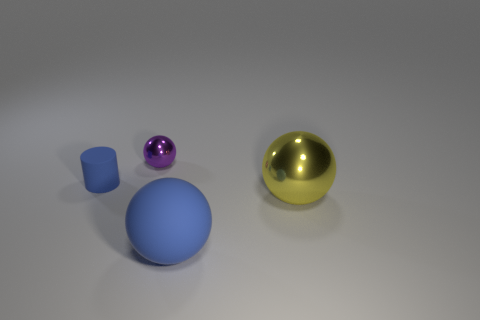What is the material of the purple sphere?
Your answer should be compact. Metal. There is a large metal thing; is it the same color as the rubber object that is on the left side of the blue ball?
Make the answer very short. No. What size is the object that is both to the right of the cylinder and left of the large blue thing?
Provide a succinct answer. Small. There is a big yellow object that is the same material as the purple thing; what shape is it?
Keep it short and to the point. Sphere. Are the small blue thing and the blue object on the right side of the purple shiny sphere made of the same material?
Your answer should be compact. Yes. There is a big thing that is left of the large yellow metallic object; are there any spheres that are in front of it?
Your response must be concise. No. What is the material of the yellow object that is the same shape as the tiny purple metal object?
Give a very brief answer. Metal. There is a rubber object in front of the large yellow shiny object; what number of small purple balls are to the right of it?
Give a very brief answer. 0. Are there any other things of the same color as the matte cylinder?
Provide a short and direct response. Yes. How many things are either big things or tiny objects that are on the right side of the small cylinder?
Give a very brief answer. 3. 